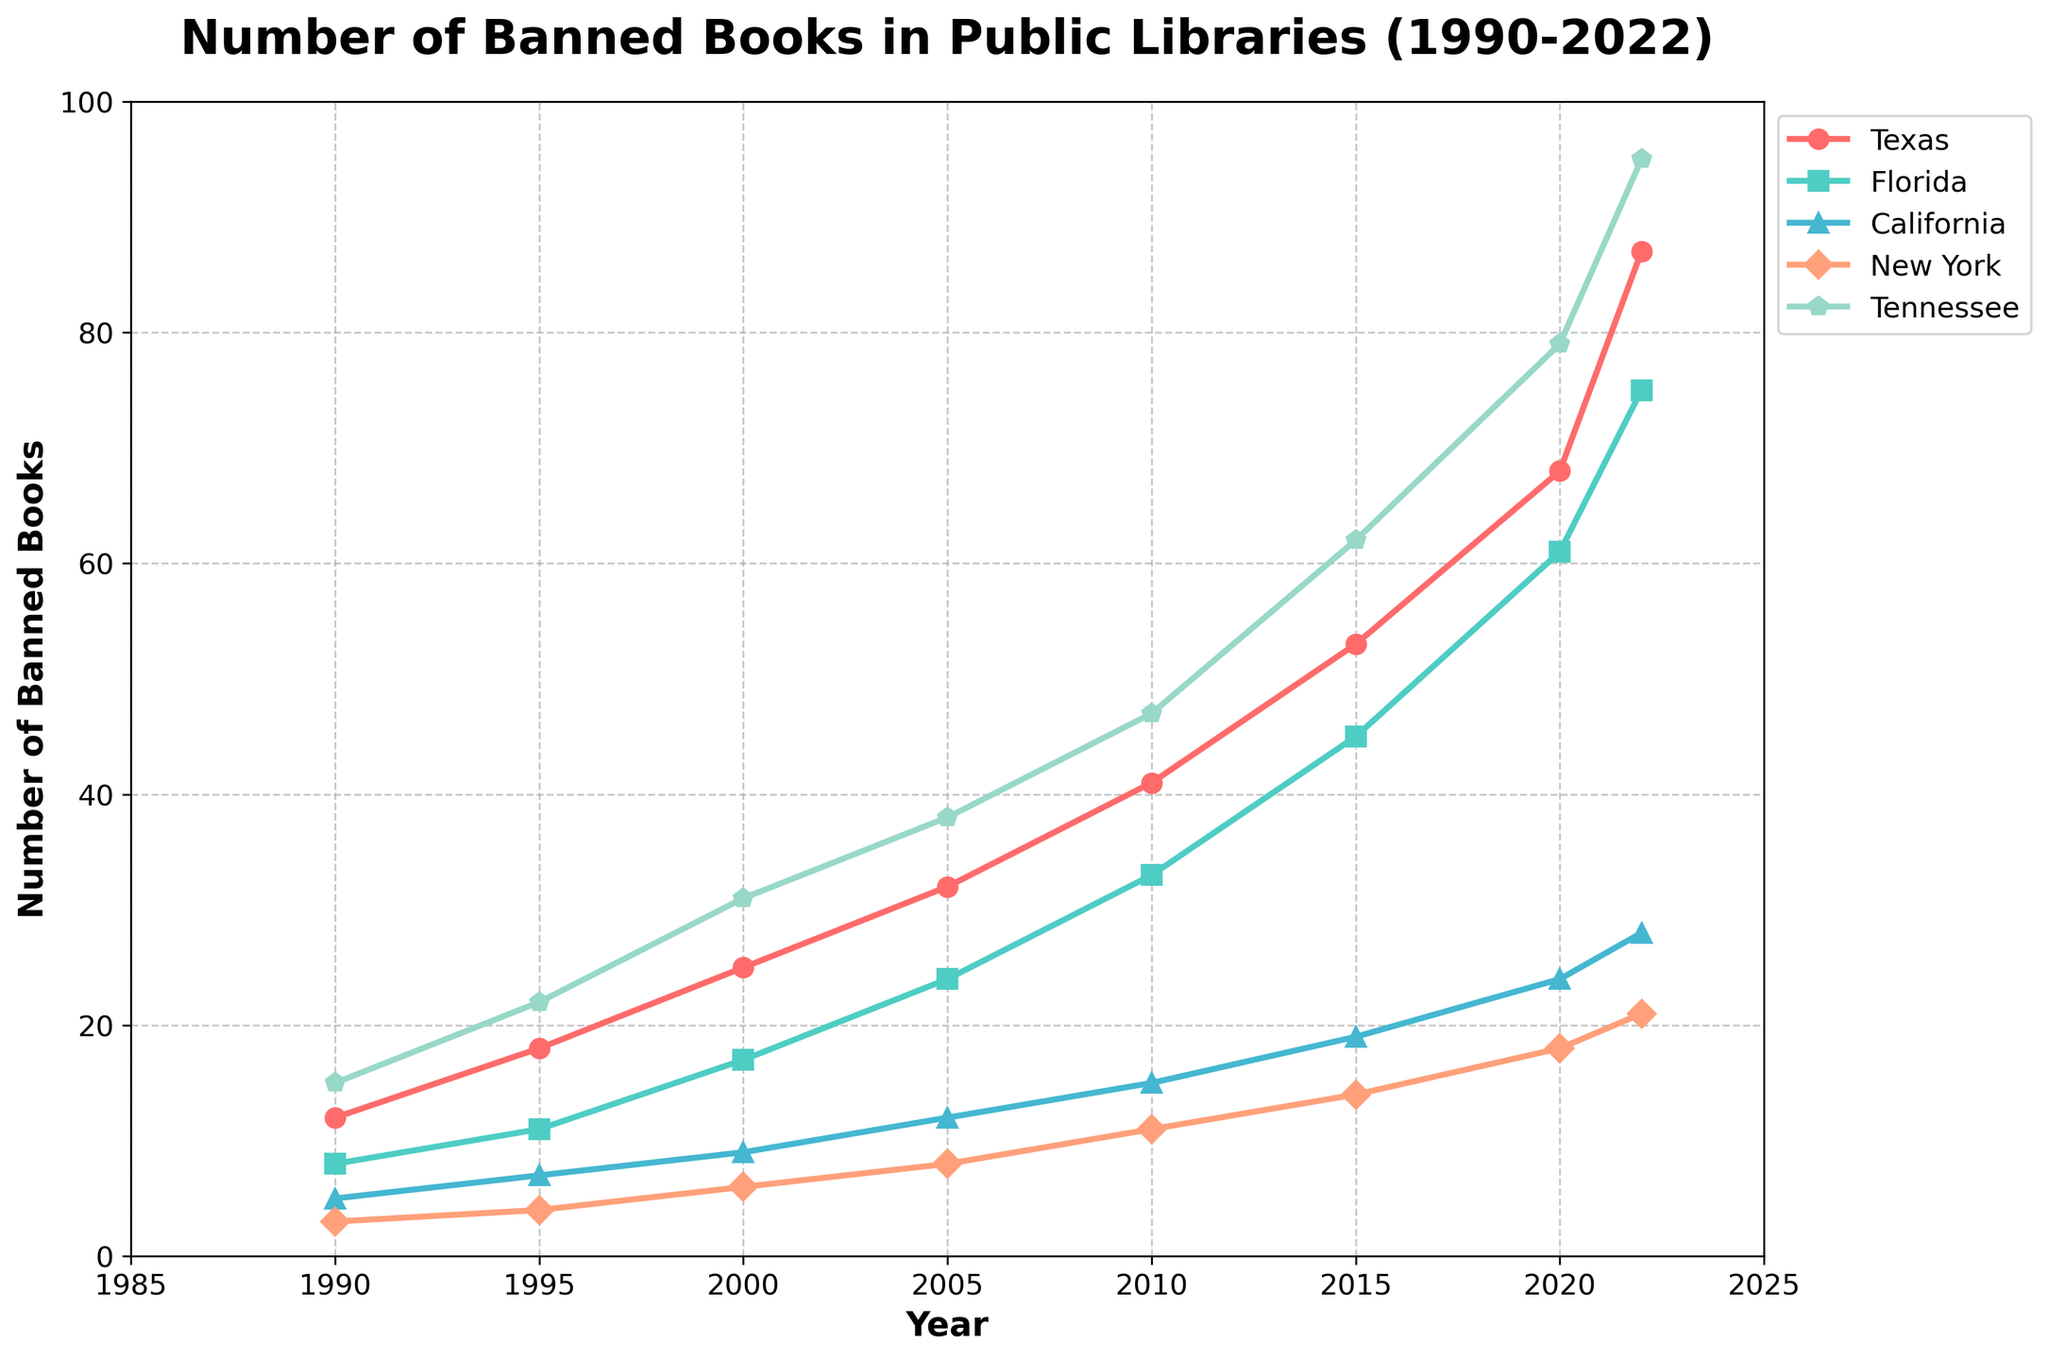What's the trend in the number of banned books in Texas from 1990 to 2022? By examining the line chart, we observe that the number of banned books in Texas has increased steadily from 1990 to 2022. In 1990, there were 12 banned books, gradually rising to 87 by 2022.
Answer: Steadily increasing Which state had the highest number of banned books in 2022? From the chart, in the year 2022, Tennessee had the highest number of banned books with 95 banned books.
Answer: Tennessee In which year did New York have the fewest banned books, and how many were they? By observing the plot for New York, the fewest banned books occurred in 1990, with a count of 3.
Answer: 1990, 3 How many more banned books were there in Texas compared to California in 2020? In 2020, Texas had 68 banned books, and California had 24. The difference is calculated as 68 - 24 = 44.
Answer: 44 Which state's banned book count grew the most between 2000 and 2015? By calculating the difference for each state between 2000 and 2015: Texas (53-25=28), Florida (45-17=28), California (19-9=10), New York (14-6=8), Tennessee (62-31=31). Therefore, Tennessee's count grew the most, by 31 books.
Answer: Tennessee What's the average number of banned books across all states in 2005? The values for 2005 are: Texas (32), Florida (24), California (12), New York (8), and Tennessee (38). The average is calculated as (32 + 24 + 12 + 8 + 38) / 5 = 22.8.
Answer: 22.8 